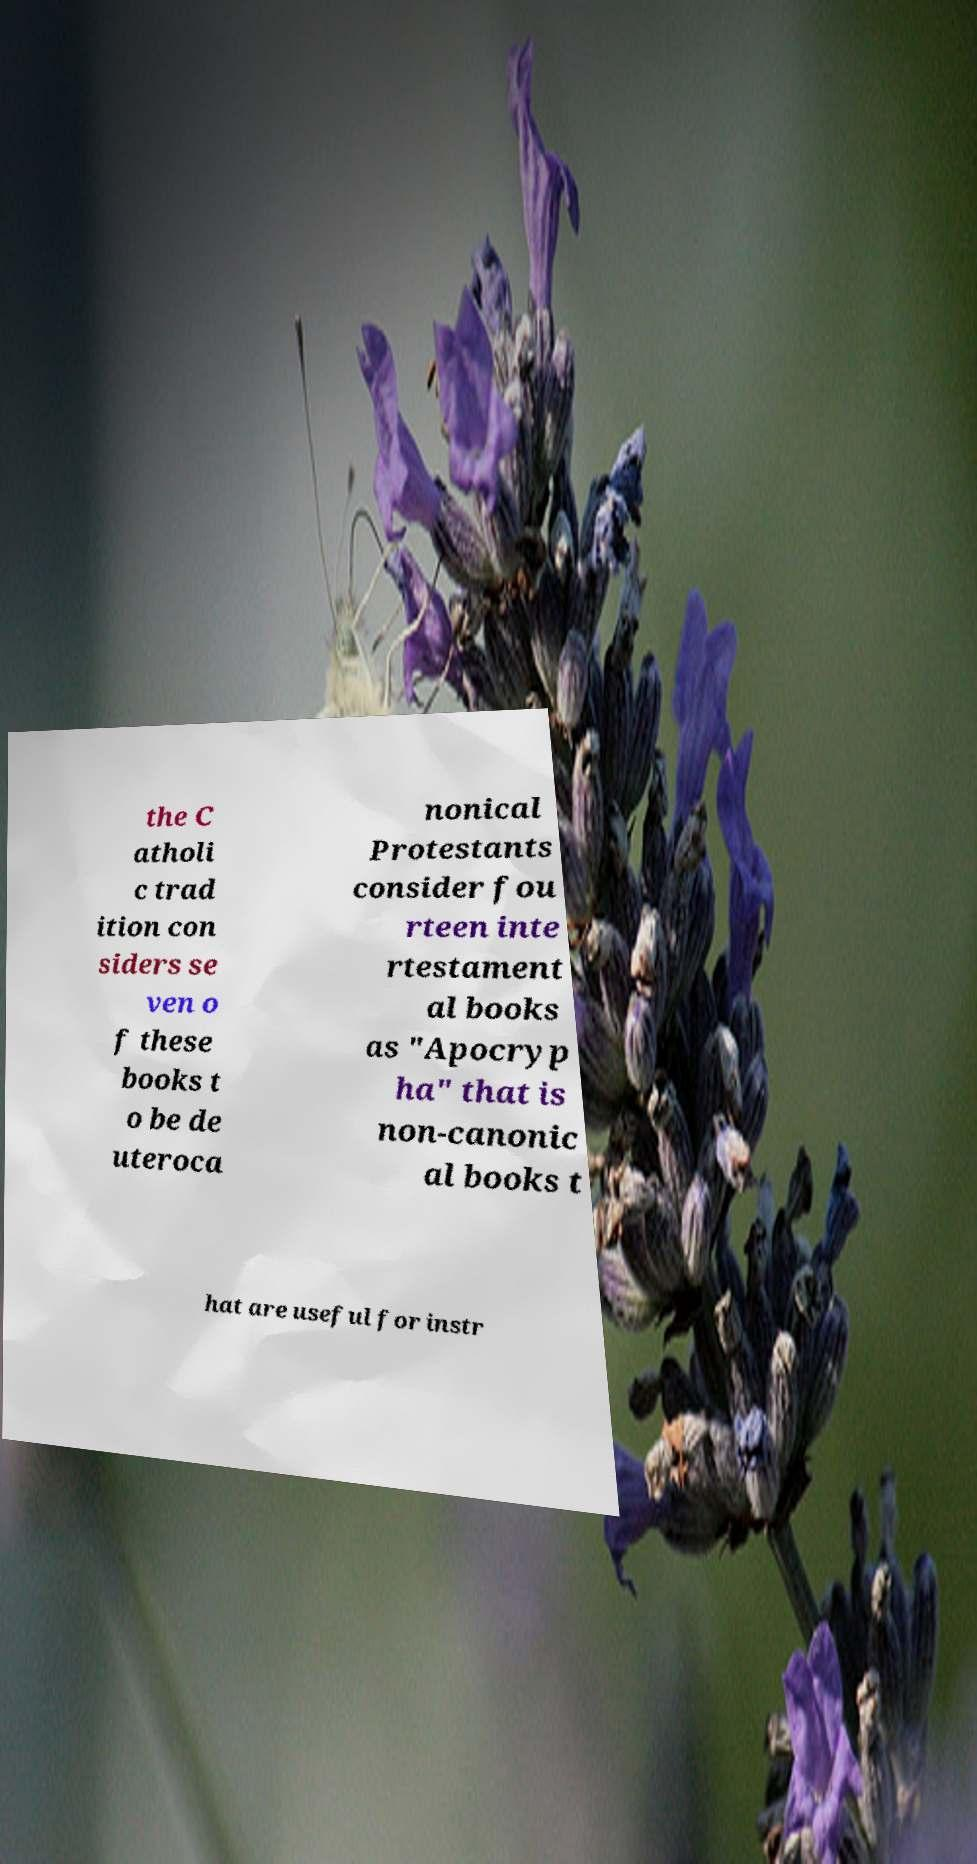Could you extract and type out the text from this image? the C atholi c trad ition con siders se ven o f these books t o be de uteroca nonical Protestants consider fou rteen inte rtestament al books as "Apocryp ha" that is non-canonic al books t hat are useful for instr 